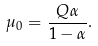Convert formula to latex. <formula><loc_0><loc_0><loc_500><loc_500>\mu _ { 0 } = \frac { Q \alpha } { 1 - \alpha } .</formula> 